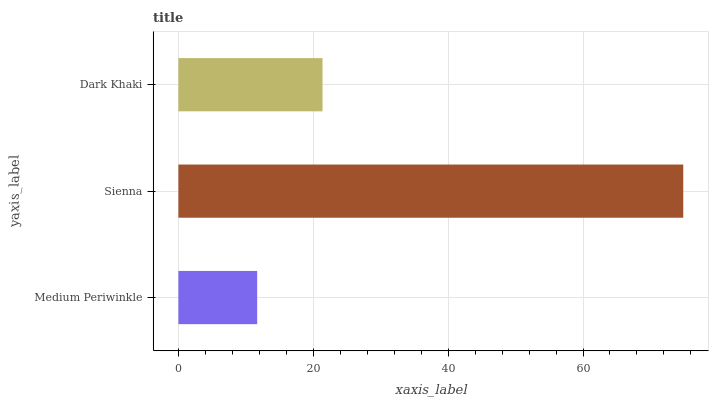Is Medium Periwinkle the minimum?
Answer yes or no. Yes. Is Sienna the maximum?
Answer yes or no. Yes. Is Dark Khaki the minimum?
Answer yes or no. No. Is Dark Khaki the maximum?
Answer yes or no. No. Is Sienna greater than Dark Khaki?
Answer yes or no. Yes. Is Dark Khaki less than Sienna?
Answer yes or no. Yes. Is Dark Khaki greater than Sienna?
Answer yes or no. No. Is Sienna less than Dark Khaki?
Answer yes or no. No. Is Dark Khaki the high median?
Answer yes or no. Yes. Is Dark Khaki the low median?
Answer yes or no. Yes. Is Medium Periwinkle the high median?
Answer yes or no. No. Is Sienna the low median?
Answer yes or no. No. 